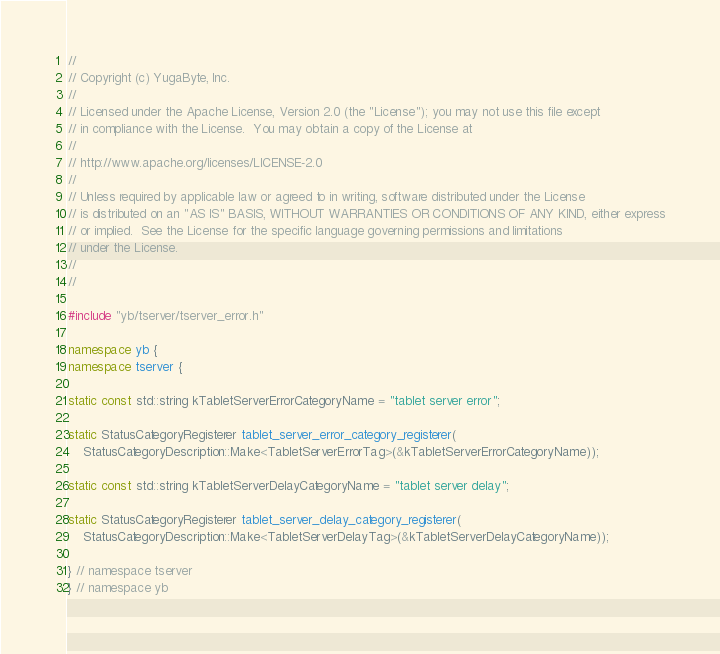Convert code to text. <code><loc_0><loc_0><loc_500><loc_500><_C++_>//
// Copyright (c) YugaByte, Inc.
//
// Licensed under the Apache License, Version 2.0 (the "License"); you may not use this file except
// in compliance with the License.  You may obtain a copy of the License at
//
// http://www.apache.org/licenses/LICENSE-2.0
//
// Unless required by applicable law or agreed to in writing, software distributed under the License
// is distributed on an "AS IS" BASIS, WITHOUT WARRANTIES OR CONDITIONS OF ANY KIND, either express
// or implied.  See the License for the specific language governing permissions and limitations
// under the License.
//
//

#include "yb/tserver/tserver_error.h"

namespace yb {
namespace tserver {

static const std::string kTabletServerErrorCategoryName = "tablet server error";

static StatusCategoryRegisterer tablet_server_error_category_registerer(
    StatusCategoryDescription::Make<TabletServerErrorTag>(&kTabletServerErrorCategoryName));

static const std::string kTabletServerDelayCategoryName = "tablet server delay";

static StatusCategoryRegisterer tablet_server_delay_category_registerer(
    StatusCategoryDescription::Make<TabletServerDelayTag>(&kTabletServerDelayCategoryName));

} // namespace tserver
} // namespace yb
</code> 